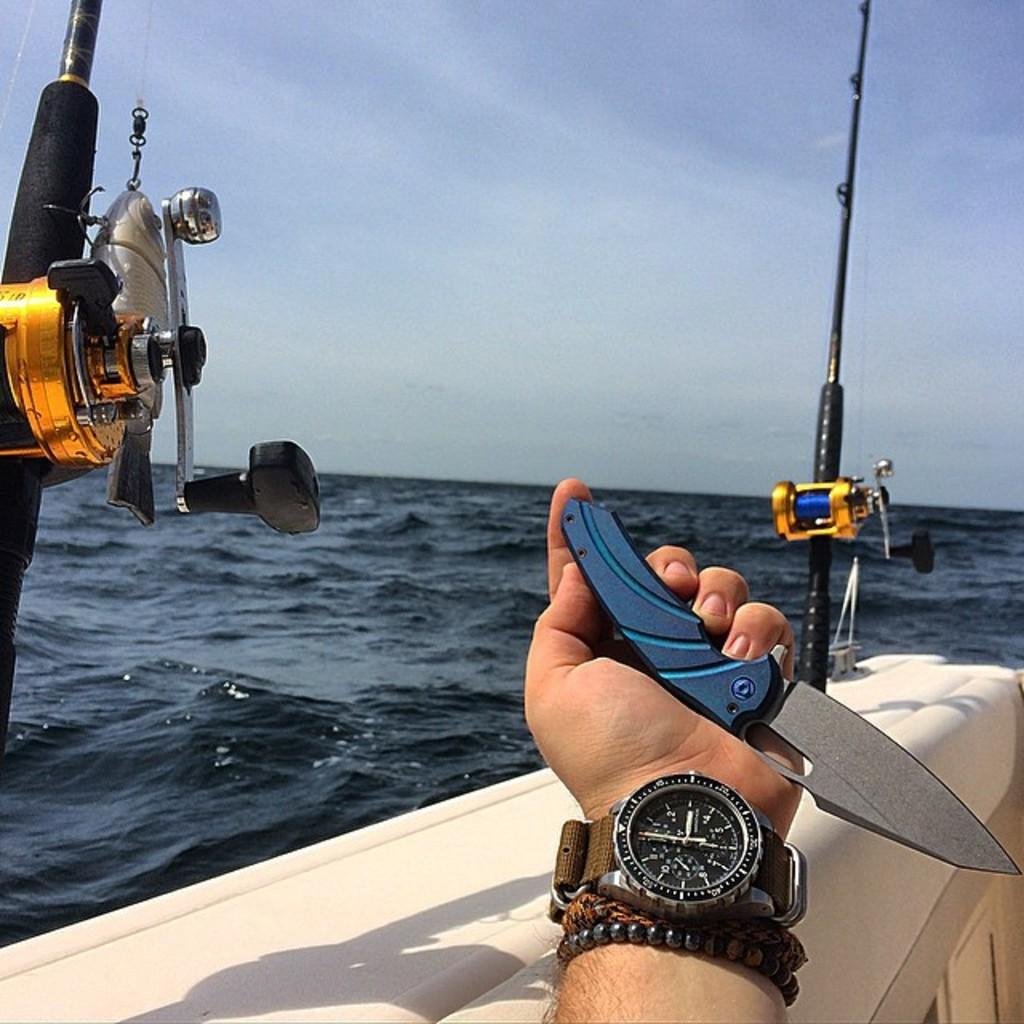Provide a one-sentence caption for the provided image. A man holding a knife and wearing a watch sitting on a fishing boat. 